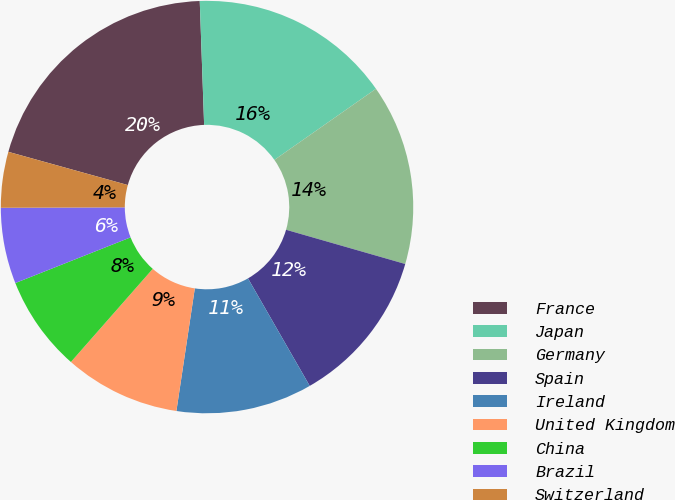<chart> <loc_0><loc_0><loc_500><loc_500><pie_chart><fcel>France<fcel>Japan<fcel>Germany<fcel>Spain<fcel>Ireland<fcel>United Kingdom<fcel>China<fcel>Brazil<fcel>Switzerland<nl><fcel>20.12%<fcel>15.84%<fcel>14.17%<fcel>12.25%<fcel>10.67%<fcel>9.1%<fcel>7.52%<fcel>5.95%<fcel>4.37%<nl></chart> 